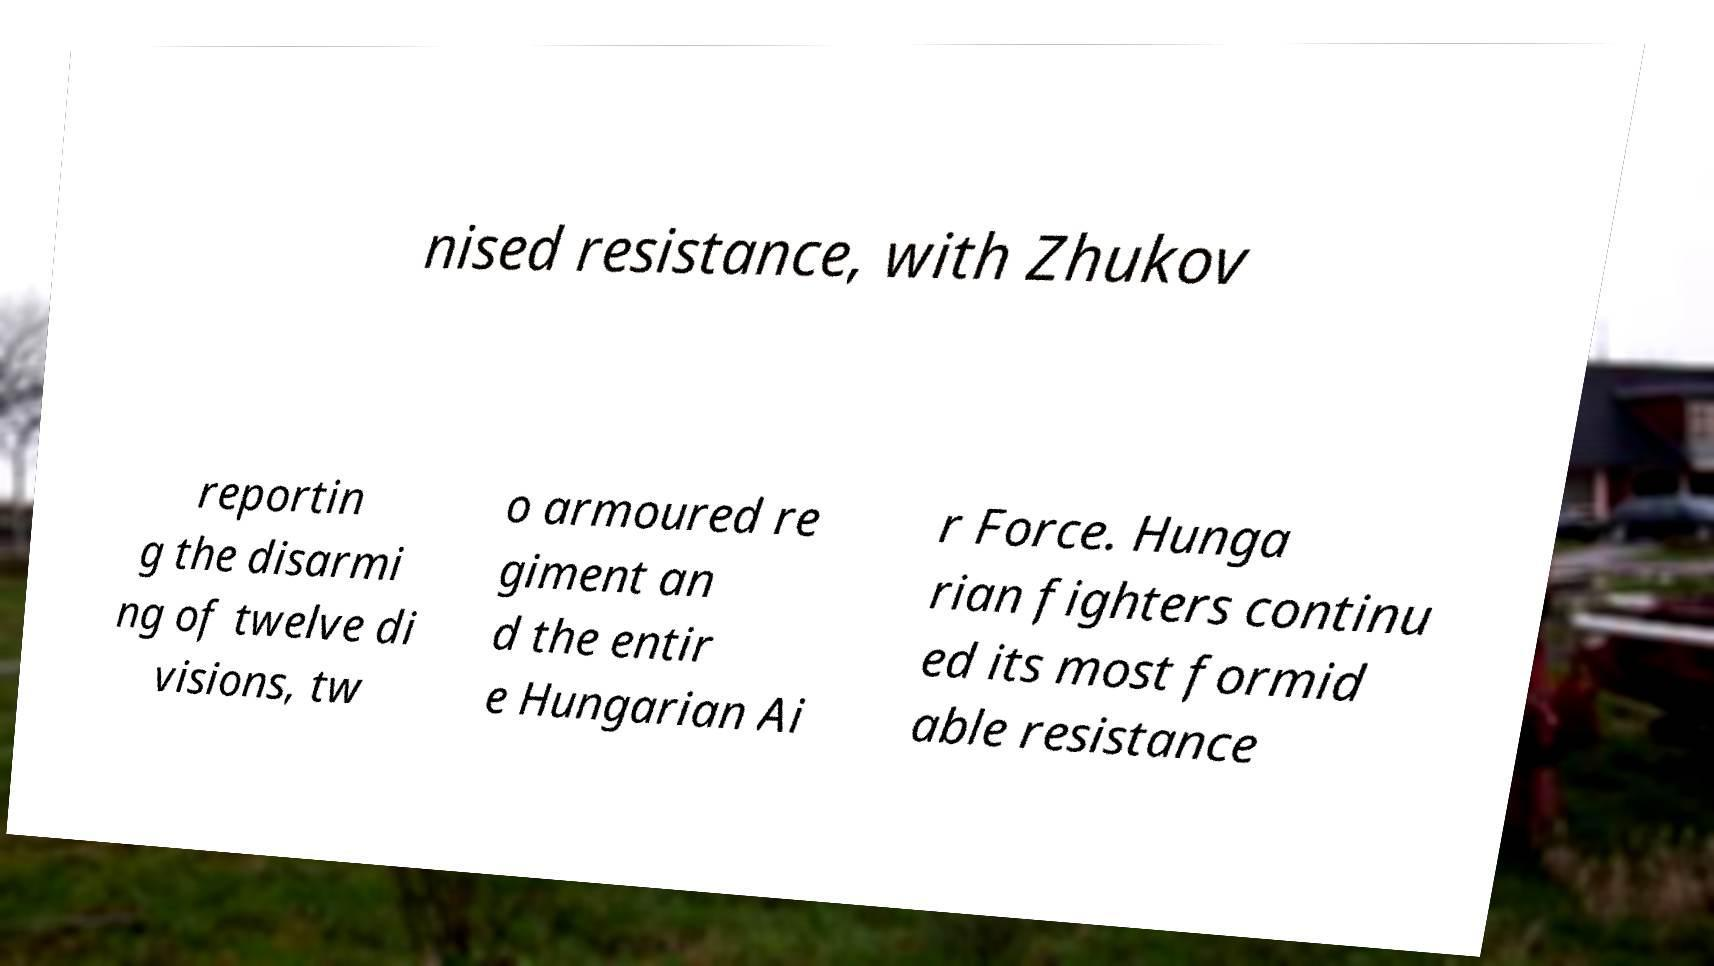Can you accurately transcribe the text from the provided image for me? nised resistance, with Zhukov reportin g the disarmi ng of twelve di visions, tw o armoured re giment an d the entir e Hungarian Ai r Force. Hunga rian fighters continu ed its most formid able resistance 